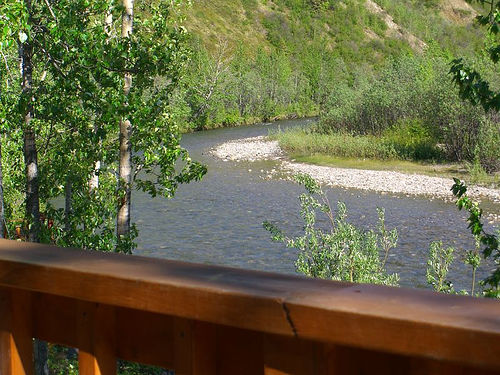<image>
Is the wood on the water? No. The wood is not positioned on the water. They may be near each other, but the wood is not supported by or resting on top of the water. 